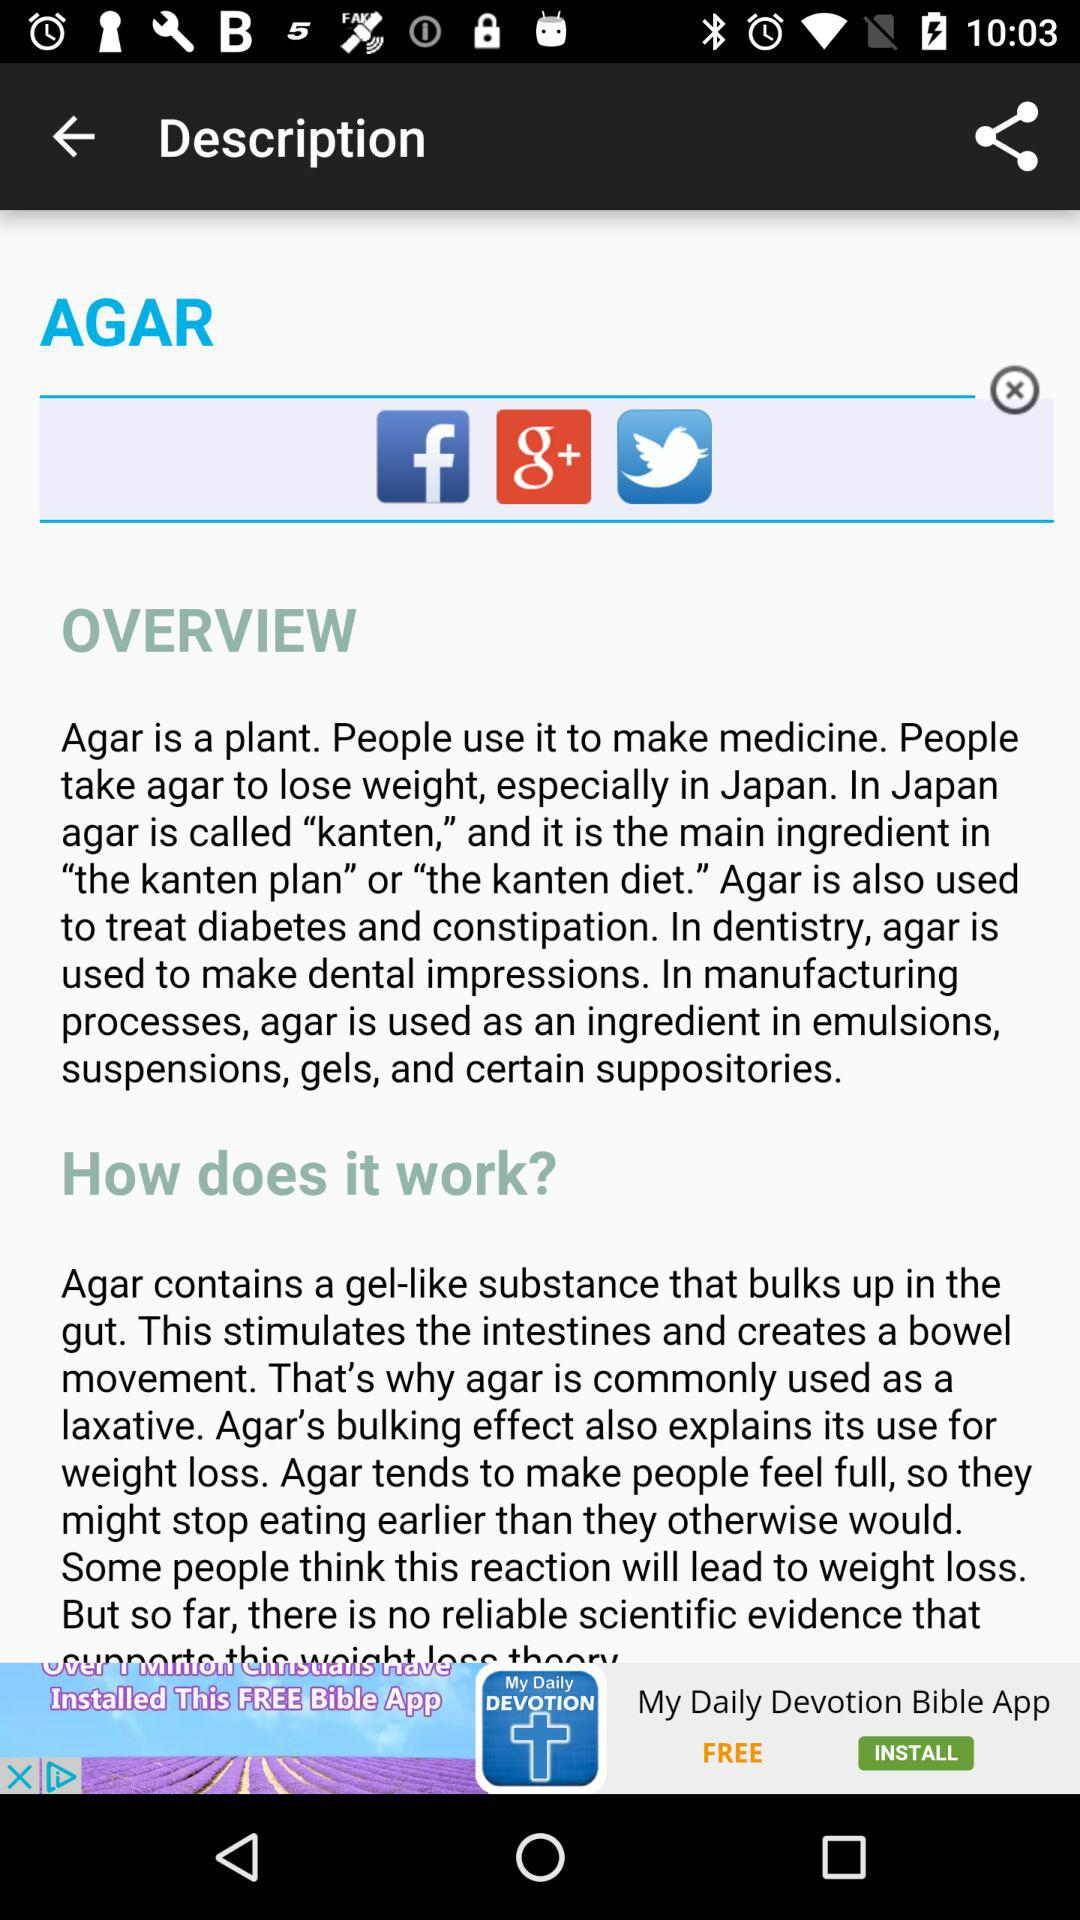How is agar useful? Agar is a plant. People use it to make medicine. People take agar to lose weight, especially in Japan. In Japan, agar is called "kanten" and it is the main ingredient in "the kanten plan" or "the kanten diet". Agar is also used to treat diabetes and constipation. In dentistry, agar is used to make dental impressions. In manufacturing processes, agar is used as an ingredient in emulsions, suspensions, gels and certain suppositories. 